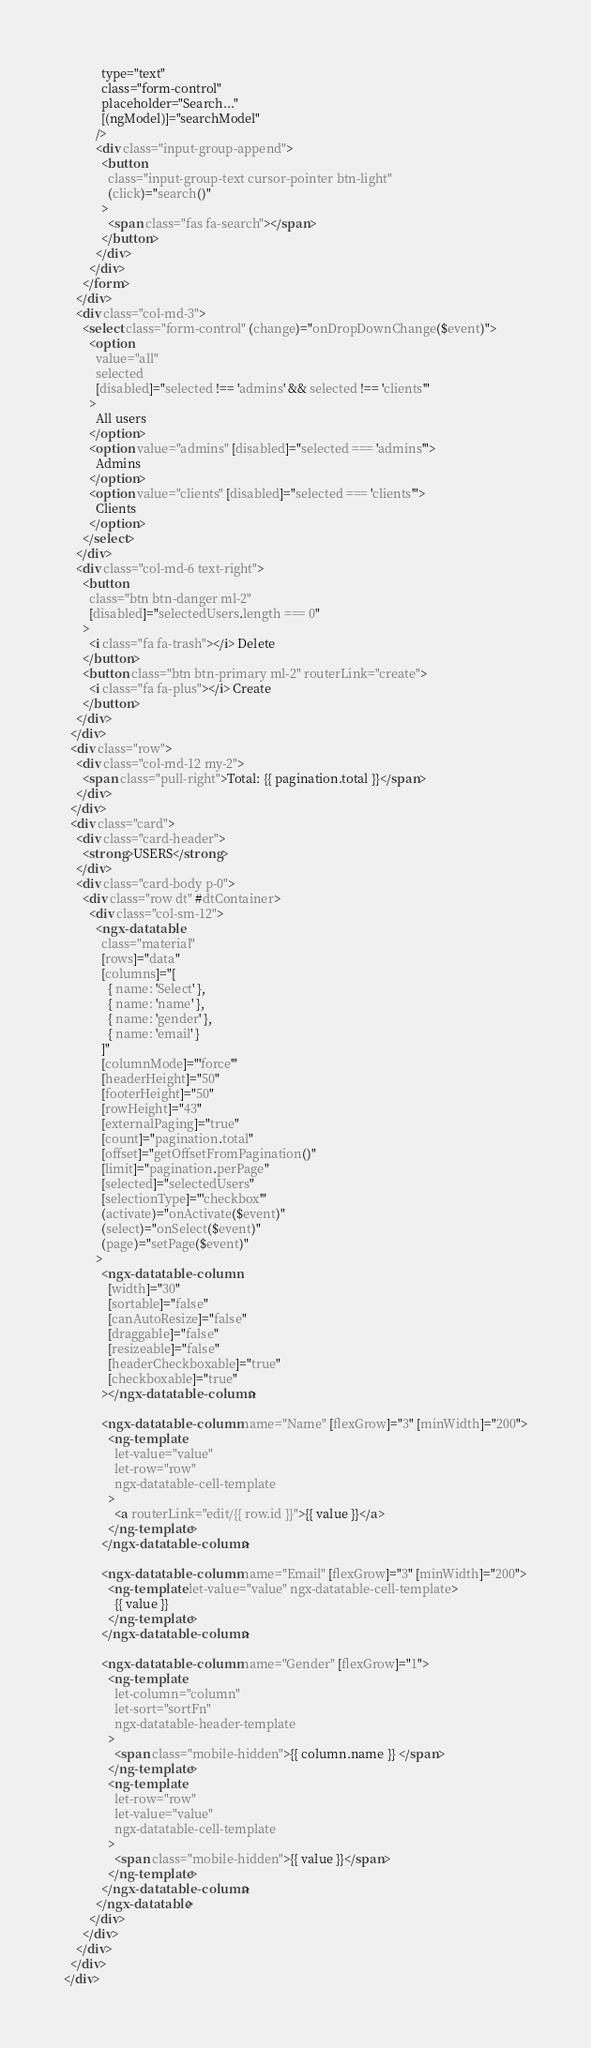Convert code to text. <code><loc_0><loc_0><loc_500><loc_500><_HTML_>            type="text"
            class="form-control"
            placeholder="Search..."
            [(ngModel)]="searchModel"
          />
          <div class="input-group-append">
            <button
              class="input-group-text cursor-pointer btn-light"
              (click)="search()"
            >
              <span class="fas fa-search"></span>
            </button>
          </div>
        </div>
      </form>
    </div>
    <div class="col-md-3">
      <select class="form-control" (change)="onDropDownChange($event)">
        <option
          value="all"
          selected
          [disabled]="selected !== 'admins' && selected !== 'clients'"
        >
          All users
        </option>
        <option value="admins" [disabled]="selected === 'admins'">
          Admins
        </option>
        <option value="clients" [disabled]="selected === 'clients'">
          Clients
        </option>
      </select>
    </div>
    <div class="col-md-6 text-right">
      <button
        class="btn btn-danger ml-2"
        [disabled]="selectedUsers.length === 0"
      >
        <i class="fa fa-trash"></i> Delete
      </button>
      <button class="btn btn-primary ml-2" routerLink="create">
        <i class="fa fa-plus"></i> Create
      </button>
    </div>
  </div>
  <div class="row">
    <div class="col-md-12 my-2">
      <span class="pull-right">Total: {{ pagination.total }}</span>
    </div>
  </div>
  <div class="card">
    <div class="card-header">
      <strong>USERS</strong>
    </div>
    <div class="card-body p-0">
      <div class="row dt" #dtContainer>
        <div class="col-sm-12">
          <ngx-datatable
            class="material"
            [rows]="data"
            [columns]="[
              { name: 'Select' },
              { name: 'name' },
              { name: 'gender' },
              { name: 'email' }
            ]"
            [columnMode]="'force'"
            [headerHeight]="50"
            [footerHeight]="50"
            [rowHeight]="43"
            [externalPaging]="true"
            [count]="pagination.total"
            [offset]="getOffsetFromPagination()"
            [limit]="pagination.perPage"
            [selected]="selectedUsers"
            [selectionType]="'checkbox'"
            (activate)="onActivate($event)"
            (select)="onSelect($event)"
            (page)="setPage($event)"
          >
            <ngx-datatable-column
              [width]="30"
              [sortable]="false"
              [canAutoResize]="false"
              [draggable]="false"
              [resizeable]="false"
              [headerCheckboxable]="true"
              [checkboxable]="true"
            ></ngx-datatable-column>

            <ngx-datatable-column name="Name" [flexGrow]="3" [minWidth]="200">
              <ng-template
                let-value="value"
                let-row="row"
                ngx-datatable-cell-template
              >
                <a routerLink="edit/{{ row.id }}">{{ value }}</a>
              </ng-template>
            </ngx-datatable-column>

            <ngx-datatable-column name="Email" [flexGrow]="3" [minWidth]="200">
              <ng-template let-value="value" ngx-datatable-cell-template>
                {{ value }}
              </ng-template>
            </ngx-datatable-column>

            <ngx-datatable-column name="Gender" [flexGrow]="1">
              <ng-template
                let-column="column"
                let-sort="sortFn"
                ngx-datatable-header-template
              >
                <span class="mobile-hidden">{{ column.name }} </span>
              </ng-template>
              <ng-template
                let-row="row"
                let-value="value"
                ngx-datatable-cell-template
              >
                <span class="mobile-hidden">{{ value }}</span>
              </ng-template>
            </ngx-datatable-column>
          </ngx-datatable>
        </div>
      </div>
    </div>
  </div>
</div>
</code> 